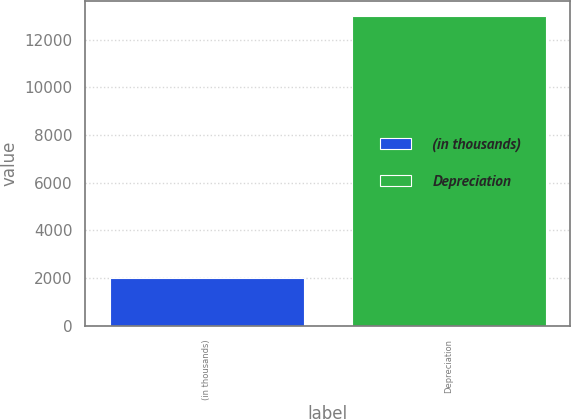Convert chart. <chart><loc_0><loc_0><loc_500><loc_500><bar_chart><fcel>(in thousands)<fcel>Depreciation<nl><fcel>2006<fcel>12976<nl></chart> 